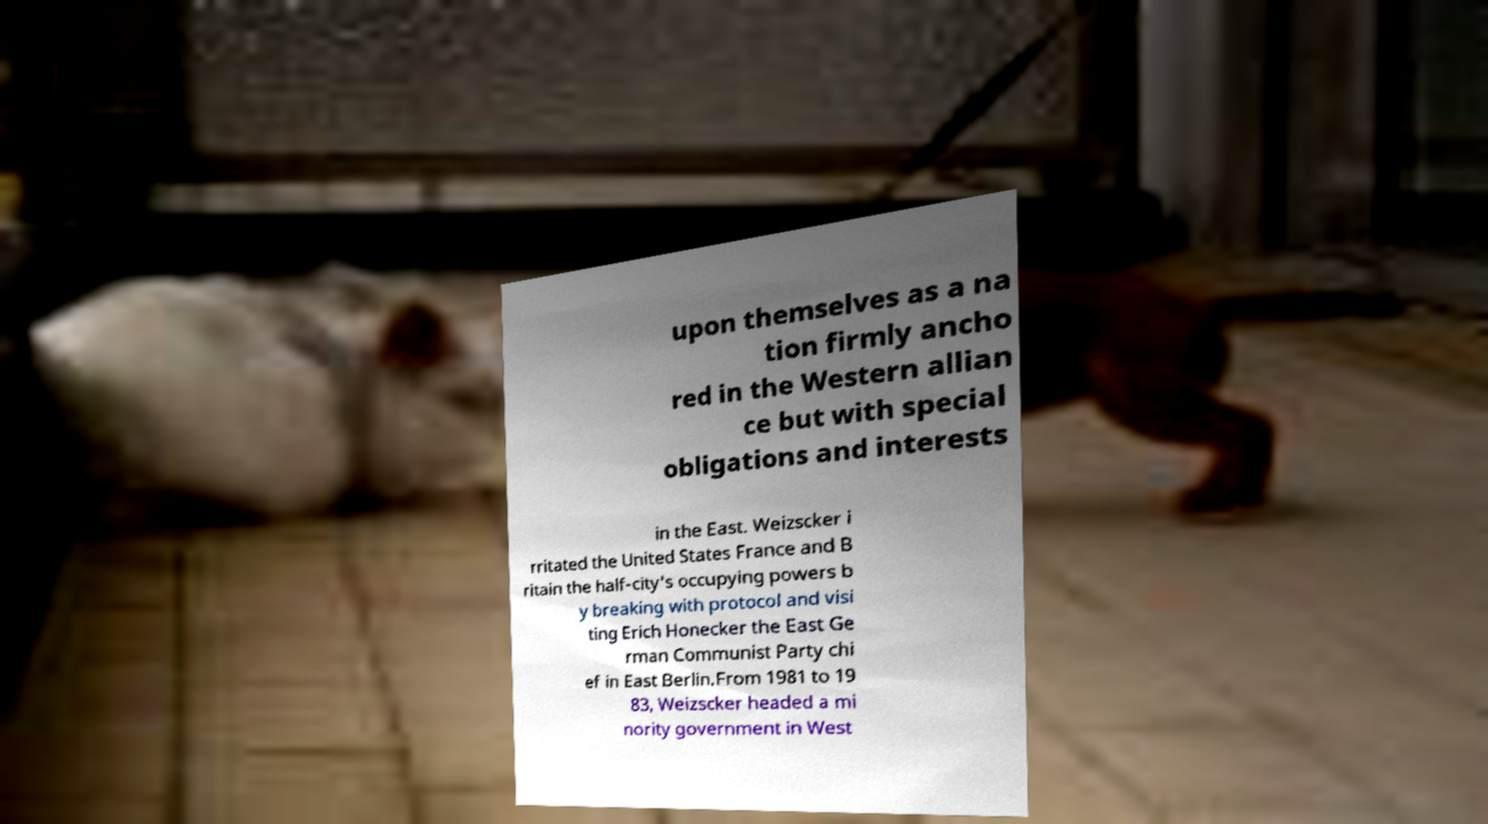Could you assist in decoding the text presented in this image and type it out clearly? upon themselves as a na tion firmly ancho red in the Western allian ce but with special obligations and interests in the East. Weizscker i rritated the United States France and B ritain the half-city's occupying powers b y breaking with protocol and visi ting Erich Honecker the East Ge rman Communist Party chi ef in East Berlin.From 1981 to 19 83, Weizscker headed a mi nority government in West 